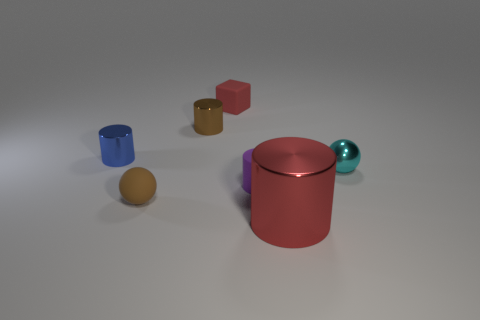Subtract all cyan cylinders. Subtract all green balls. How many cylinders are left? 4 Add 2 brown objects. How many objects exist? 9 Subtract all cubes. How many objects are left? 6 Add 5 small purple cylinders. How many small purple cylinders exist? 6 Subtract 0 yellow cubes. How many objects are left? 7 Subtract all tiny gray matte cylinders. Subtract all tiny rubber cylinders. How many objects are left? 6 Add 5 brown matte things. How many brown matte things are left? 6 